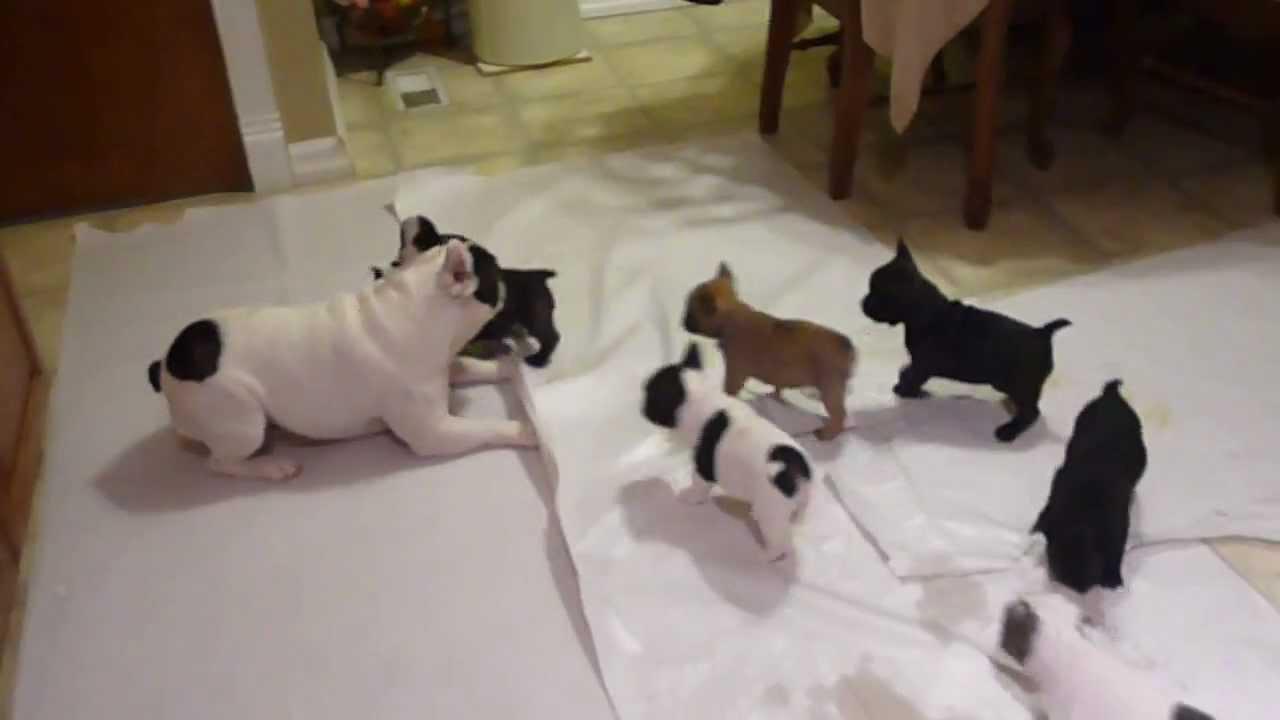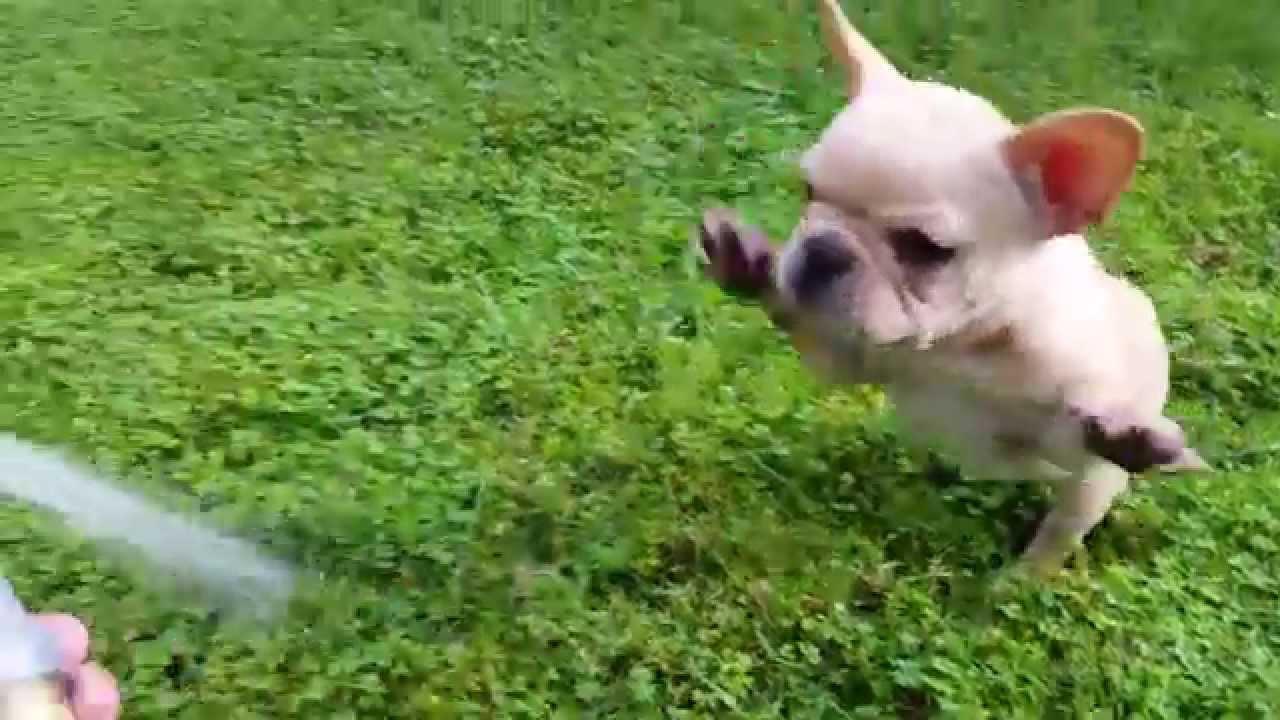The first image is the image on the left, the second image is the image on the right. Examine the images to the left and right. Is the description "The right image contains at least two dogs." accurate? Answer yes or no. No. The first image is the image on the left, the second image is the image on the right. Assess this claim about the two images: "One image shows a tan big-eared dog standing with its body turned forward and holding a solid-colored toy in its mouth.". Correct or not? Answer yes or no. No. 